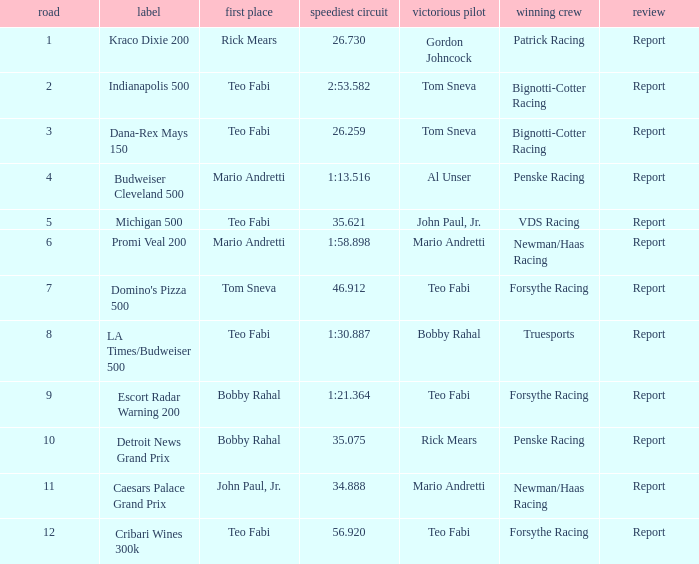How many reports are there in the race that Forsythe Racing won and Teo Fabi had the pole position in? 1.0. 